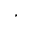Convert formula to latex. <formula><loc_0><loc_0><loc_500><loc_500>^ { ^ { * } }</formula> 